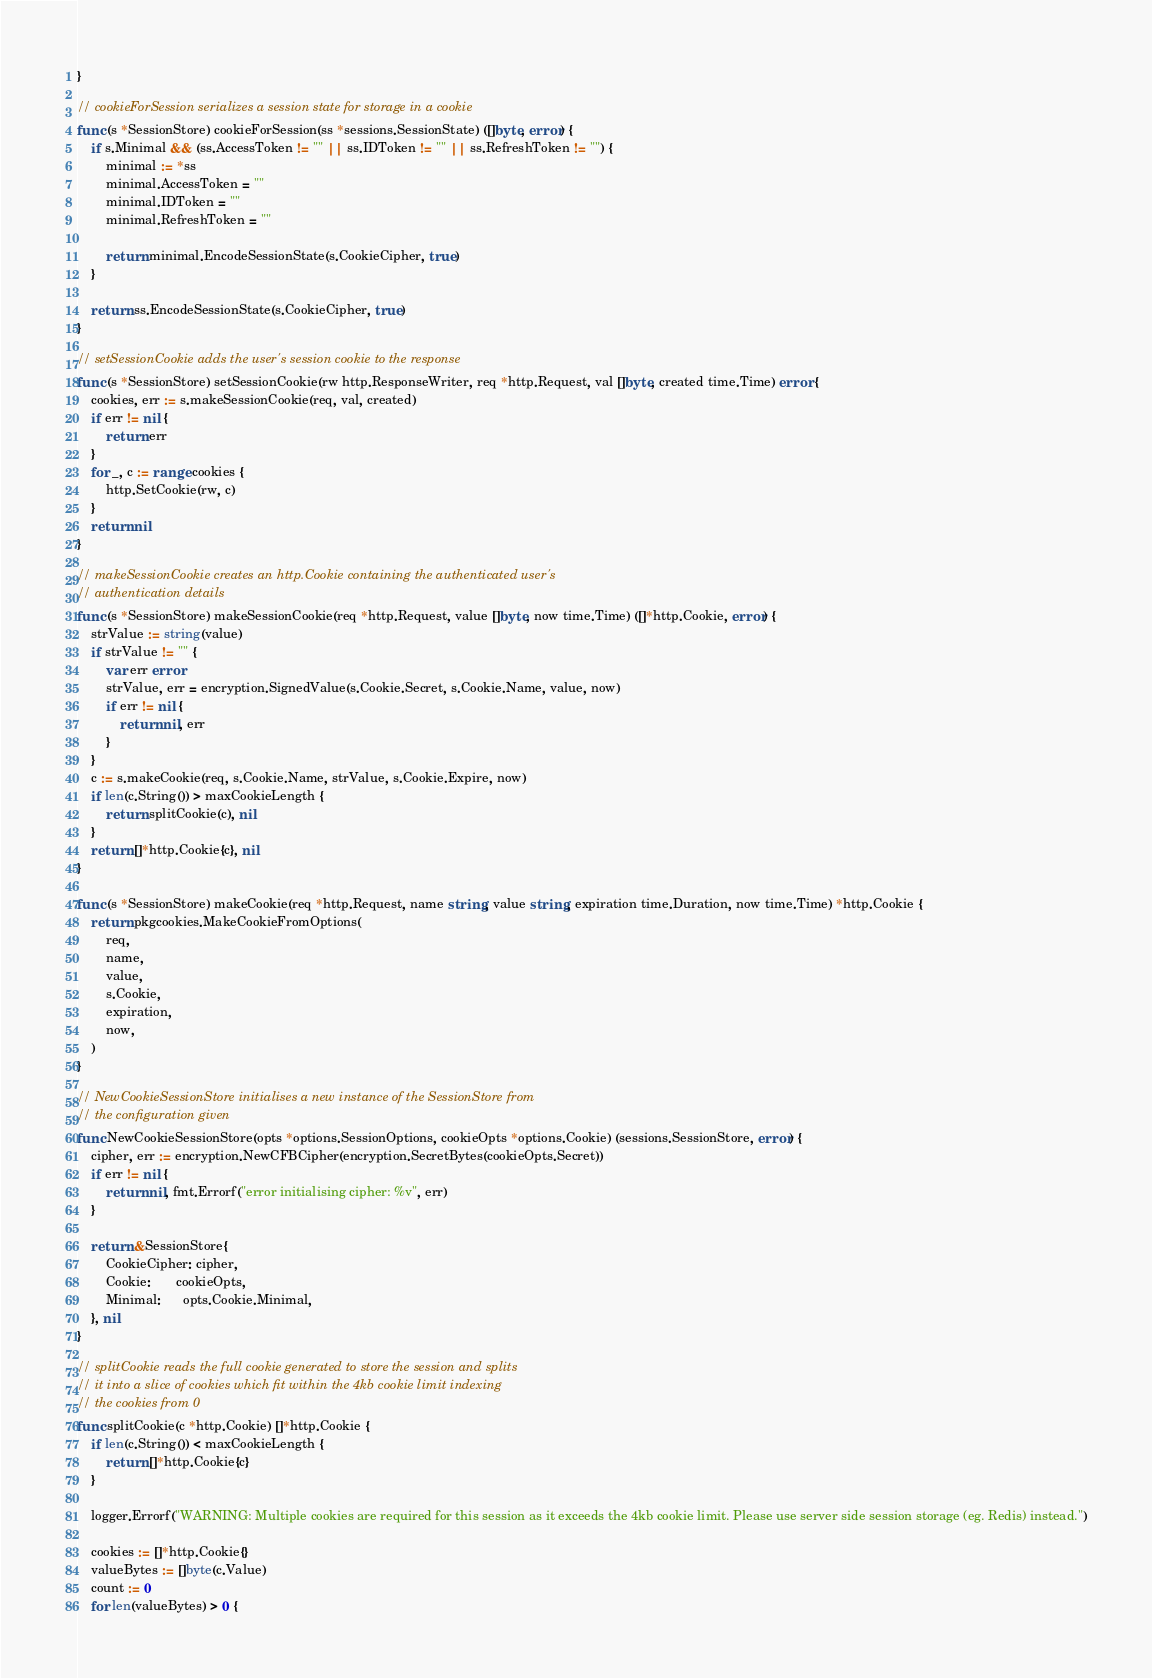<code> <loc_0><loc_0><loc_500><loc_500><_Go_>}

// cookieForSession serializes a session state for storage in a cookie
func (s *SessionStore) cookieForSession(ss *sessions.SessionState) ([]byte, error) {
	if s.Minimal && (ss.AccessToken != "" || ss.IDToken != "" || ss.RefreshToken != "") {
		minimal := *ss
		minimal.AccessToken = ""
		minimal.IDToken = ""
		minimal.RefreshToken = ""

		return minimal.EncodeSessionState(s.CookieCipher, true)
	}

	return ss.EncodeSessionState(s.CookieCipher, true)
}

// setSessionCookie adds the user's session cookie to the response
func (s *SessionStore) setSessionCookie(rw http.ResponseWriter, req *http.Request, val []byte, created time.Time) error {
	cookies, err := s.makeSessionCookie(req, val, created)
	if err != nil {
		return err
	}
	for _, c := range cookies {
		http.SetCookie(rw, c)
	}
	return nil
}

// makeSessionCookie creates an http.Cookie containing the authenticated user's
// authentication details
func (s *SessionStore) makeSessionCookie(req *http.Request, value []byte, now time.Time) ([]*http.Cookie, error) {
	strValue := string(value)
	if strValue != "" {
		var err error
		strValue, err = encryption.SignedValue(s.Cookie.Secret, s.Cookie.Name, value, now)
		if err != nil {
			return nil, err
		}
	}
	c := s.makeCookie(req, s.Cookie.Name, strValue, s.Cookie.Expire, now)
	if len(c.String()) > maxCookieLength {
		return splitCookie(c), nil
	}
	return []*http.Cookie{c}, nil
}

func (s *SessionStore) makeCookie(req *http.Request, name string, value string, expiration time.Duration, now time.Time) *http.Cookie {
	return pkgcookies.MakeCookieFromOptions(
		req,
		name,
		value,
		s.Cookie,
		expiration,
		now,
	)
}

// NewCookieSessionStore initialises a new instance of the SessionStore from
// the configuration given
func NewCookieSessionStore(opts *options.SessionOptions, cookieOpts *options.Cookie) (sessions.SessionStore, error) {
	cipher, err := encryption.NewCFBCipher(encryption.SecretBytes(cookieOpts.Secret))
	if err != nil {
		return nil, fmt.Errorf("error initialising cipher: %v", err)
	}

	return &SessionStore{
		CookieCipher: cipher,
		Cookie:       cookieOpts,
		Minimal:      opts.Cookie.Minimal,
	}, nil
}

// splitCookie reads the full cookie generated to store the session and splits
// it into a slice of cookies which fit within the 4kb cookie limit indexing
// the cookies from 0
func splitCookie(c *http.Cookie) []*http.Cookie {
	if len(c.String()) < maxCookieLength {
		return []*http.Cookie{c}
	}

	logger.Errorf("WARNING: Multiple cookies are required for this session as it exceeds the 4kb cookie limit. Please use server side session storage (eg. Redis) instead.")

	cookies := []*http.Cookie{}
	valueBytes := []byte(c.Value)
	count := 0
	for len(valueBytes) > 0 {</code> 